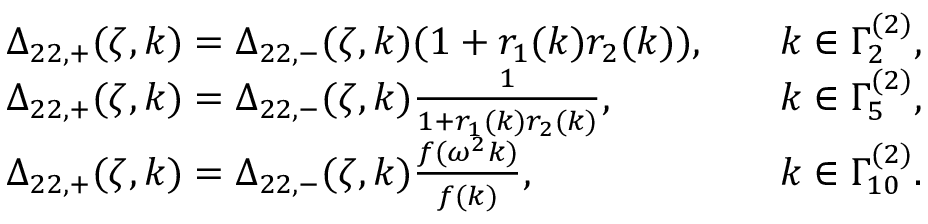<formula> <loc_0><loc_0><loc_500><loc_500>\begin{array} { r l r l } & { \Delta _ { 2 2 , + } ( \zeta , k ) = \Delta _ { 2 2 , - } ( \zeta , k ) ( 1 + r _ { 1 } ( k ) r _ { 2 } ( k ) ) , } & & { k \in \Gamma _ { 2 } ^ { ( 2 ) } , } \\ & { \Delta _ { 2 2 , + } ( \zeta , k ) = \Delta _ { 2 2 , - } ( \zeta , k ) \frac { 1 } { 1 + r _ { 1 } ( k ) r _ { 2 } ( k ) } , } & & { k \in \Gamma _ { 5 } ^ { ( 2 ) } , } \\ & { \Delta _ { 2 2 , + } ( \zeta , k ) = \Delta _ { 2 2 , - } ( \zeta , k ) \frac { f ( \omega ^ { 2 } k ) } { f ( k ) } , } & & { k \in \Gamma _ { 1 0 } ^ { ( 2 ) } . } \end{array}</formula> 